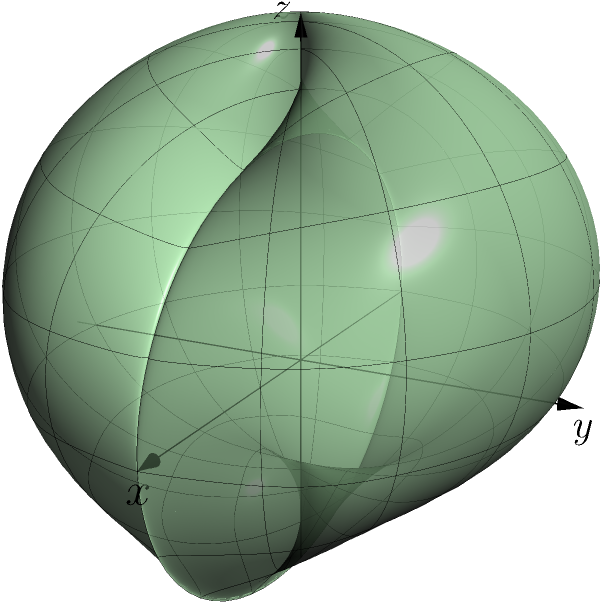In a geological survey of an underground mineral deposit, you've modeled the concentration of the resource using spherical coordinates $(r, \theta, \phi)$. The radial distance $r$ (in km) from the center of the deposit is given by the function:

$$r(\theta, \phi) = 2 + \cos\phi \sin\theta$$

Where $\theta$ is the azimuthal angle in the x-y plane from the x-axis (0 to 2π), and $\phi$ is the polar angle from the z-axis (0 to π).

What is the maximum radial distance of the mineral concentration from the center of the deposit? To find the maximum radial distance, we need to maximize the function $r(\theta, \phi)$. Let's approach this step-by-step:

1) The function is given as: $r(\theta, \phi) = 2 + \cos\phi \sin\theta$

2) The constant term 2 doesn't depend on $\theta$ or $\phi$, so we need to maximize $\cos\phi \sin\theta$

3) The maximum value of $\sin\theta$ is 1, which occurs when $\theta = \frac{\pi}{2}$ or $\frac{3\pi}{2}$

4) The maximum value of $\cos\phi$ is 1, which occurs when $\phi = 0$ or $2\pi$

5) Therefore, the maximum value of $\cos\phi \sin\theta$ is 1, occurring when $\theta = \frac{\pi}{2}$ (or $\frac{3\pi}{2}$) and $\phi = 0$ (or $2\pi$)

6) Substituting this maximum value back into the original function:

   $r_{max} = 2 + 1 = 3$

Thus, the maximum radial distance of the mineral concentration from the center of the deposit is 3 km.
Answer: 3 km 